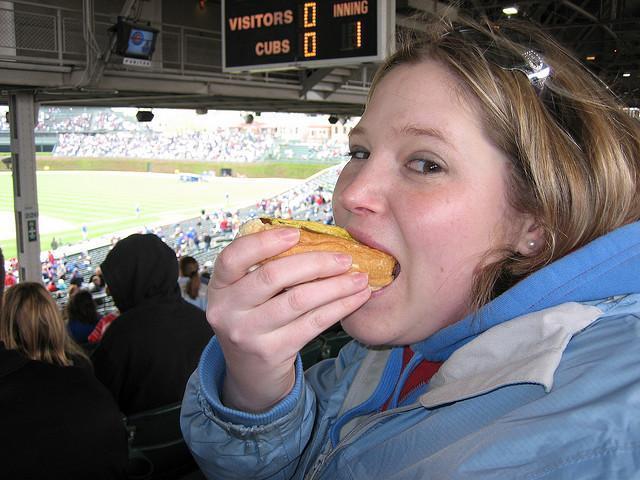How many people can be seen?
Give a very brief answer. 4. How many chairs can be seen?
Give a very brief answer. 0. 